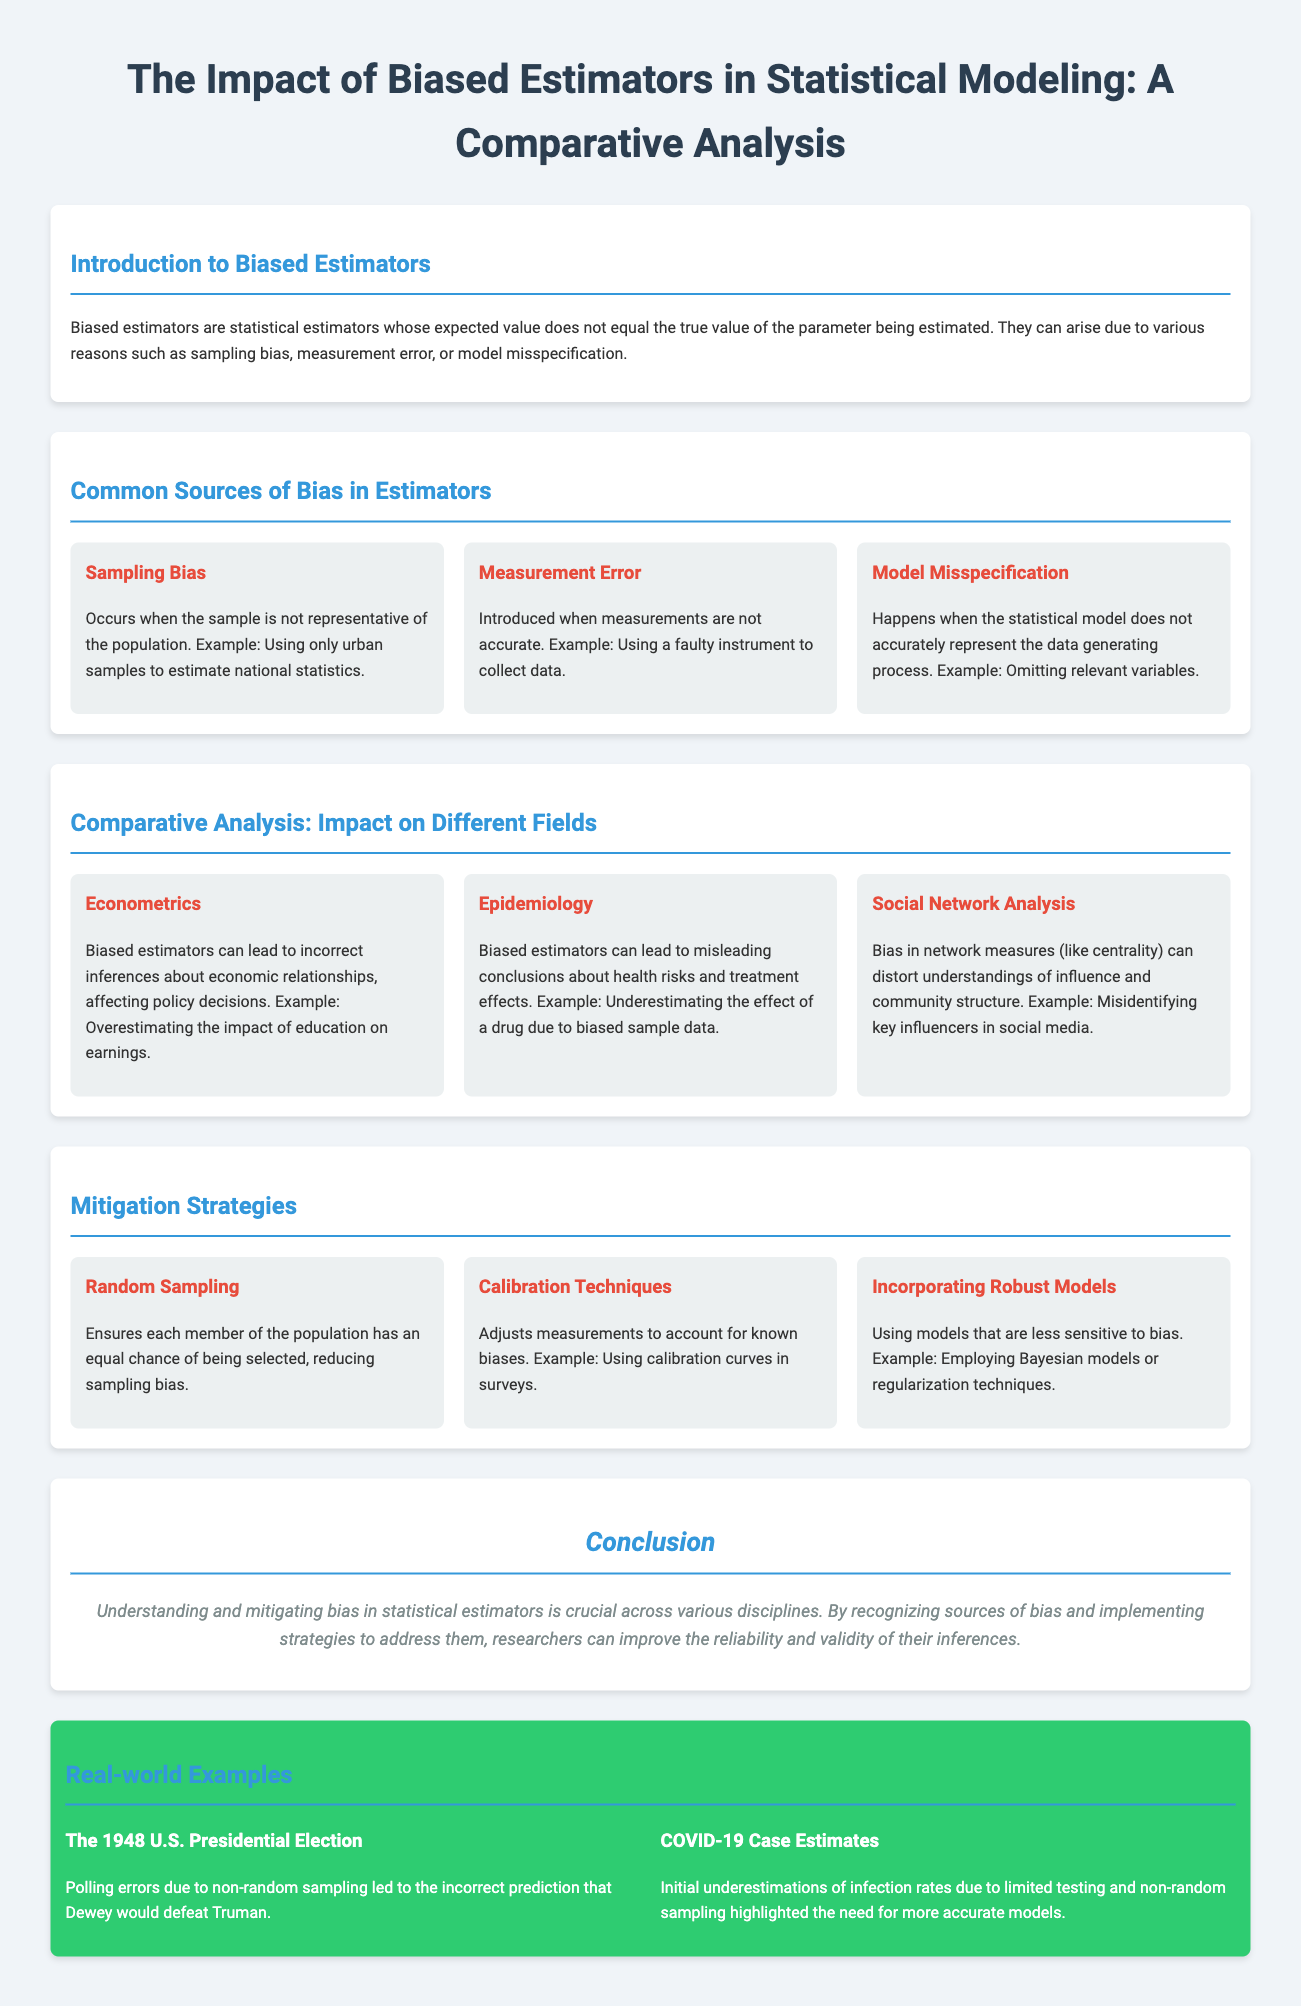What are biased estimators? Biased estimators are statistical estimators whose expected value does not equal the true value of the parameter being estimated.
Answer: Statistical estimators What is a common source of bias that arises from using non-representative samples? Sampling bias occurs when the sample is not representative of the population.
Answer: Sampling bias In which field can biased estimators affect policy decisions? Biased estimators can lead to incorrect inferences about economic relationships, affecting policy decisions.
Answer: Econometrics What mitigation strategy ensures equal chances for all population members in selection? Random Sampling ensures each member of the population has an equal chance of being selected.
Answer: Random Sampling Which historical event illustrates polling errors due to biased estimators? The 1948 U.S. Presidential Election.
Answer: The 1948 U.S. Presidential Election What is the impact of biased estimators on health risk conclusions? Biased estimators can lead to misleading conclusions about health risks and treatment effects.
Answer: Misleading conclusions What does model misspecification typically involve? Model misspecification happens when the statistical model does not accurately represent the data generating process.
Answer: Model misspecification What does calibration techniques aim to adjust for? Calibration techniques adjust measurements to account for known biases.
Answer: Known biases Which example highlights the need for accurate models during the COVID-19 pandemic? Initial underestimations of infection rates due to limited testing and non-random sampling.
Answer: COVID-19 Case Estimates 